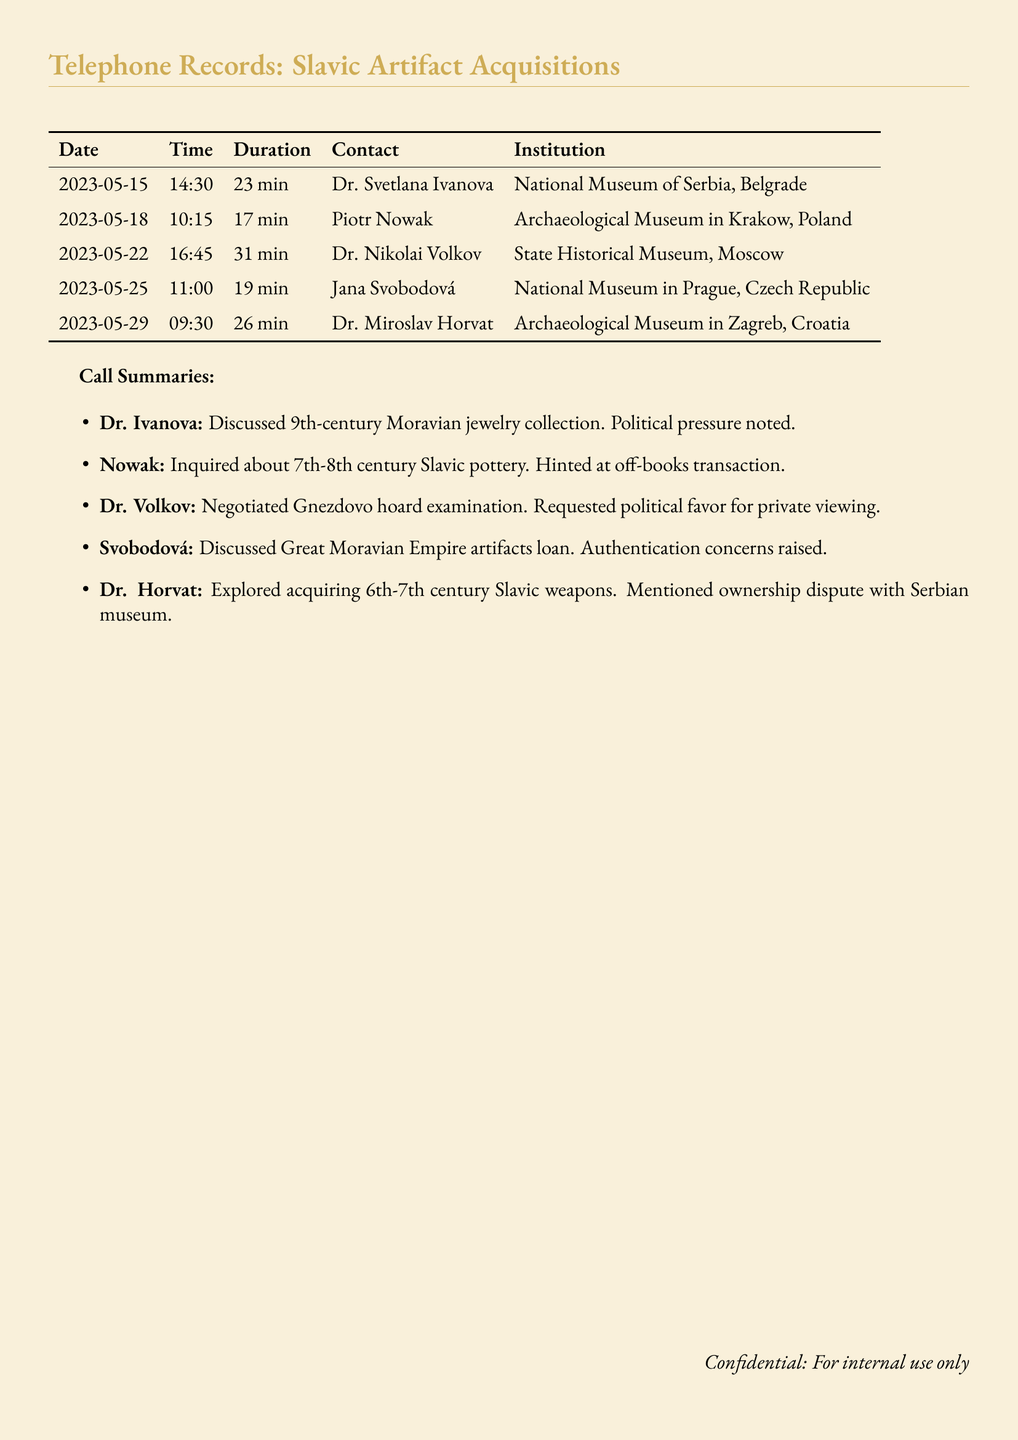What is the date of the call with Dr. Svetlana Ivanova? The call with Dr. Svetlana Ivanova occurred on May 15, 2023.
Answer: May 15, 2023 How long did the conversation with Piotr Nowak last? The duration of the conversation with Piotr Nowak was 17 minutes.
Answer: 17 min What artifact type was discussed with Dr. Nikolai Volkov? The artifact type discussed with Dr. Nikolai Volkov was the Gnezdovo hoard.
Answer: Gnezdovo hoard Who mentioned concerns regarding authentication? Jana Svobodová mentioned authentication concerns.
Answer: Jana Svobodová What was the primary concern raised during the call with Dr. Miroslav Horvat? The primary concern was an ownership dispute with a Serbian museum.
Answer: Ownership dispute with Serbian museum How many calls are documented in total? There are five calls documented in total.
Answer: 5 What was the institution associated with the call to Piotr Nowak? The institution associated with the call to Piotr Nowak was the Archaeological Museum in Krakow, Poland.
Answer: Archaeological Museum in Krakow, Poland What type of transaction was hinted at during the call with Piotr Nowak? An off-books transaction was hinted at during the call.
Answer: Off-books transaction 